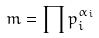<formula> <loc_0><loc_0><loc_500><loc_500>m = \prod p _ { i } ^ { \alpha _ { i } }</formula> 